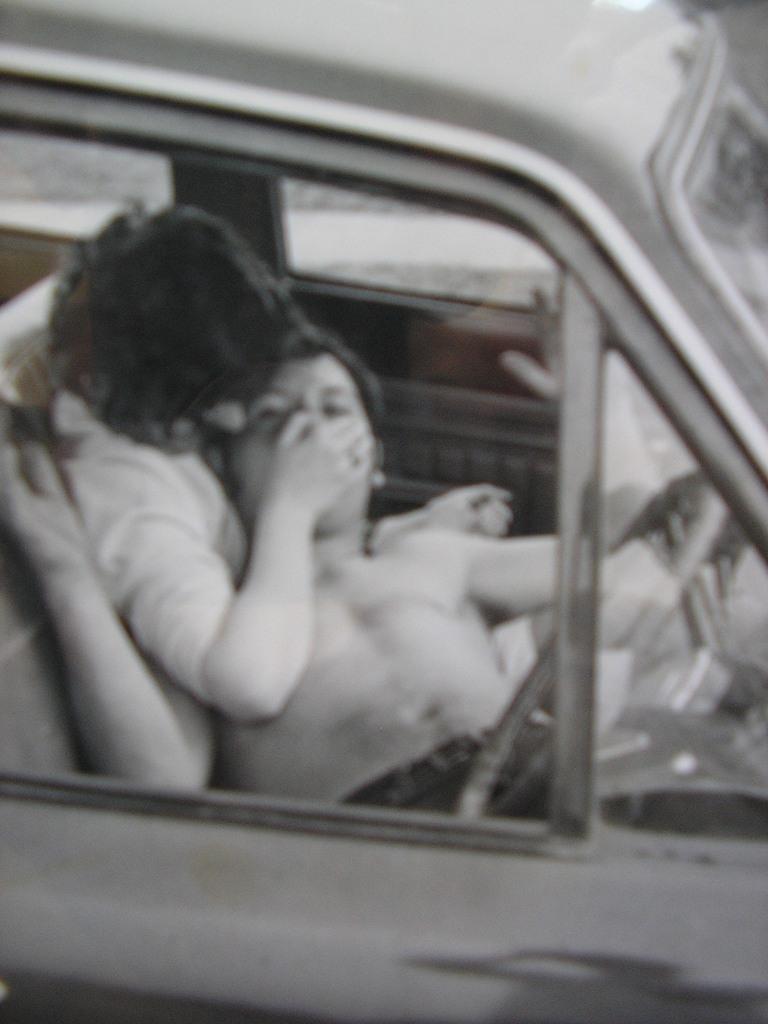How would you summarize this image in a sentence or two? In this Image I see 2 persons in the car. 